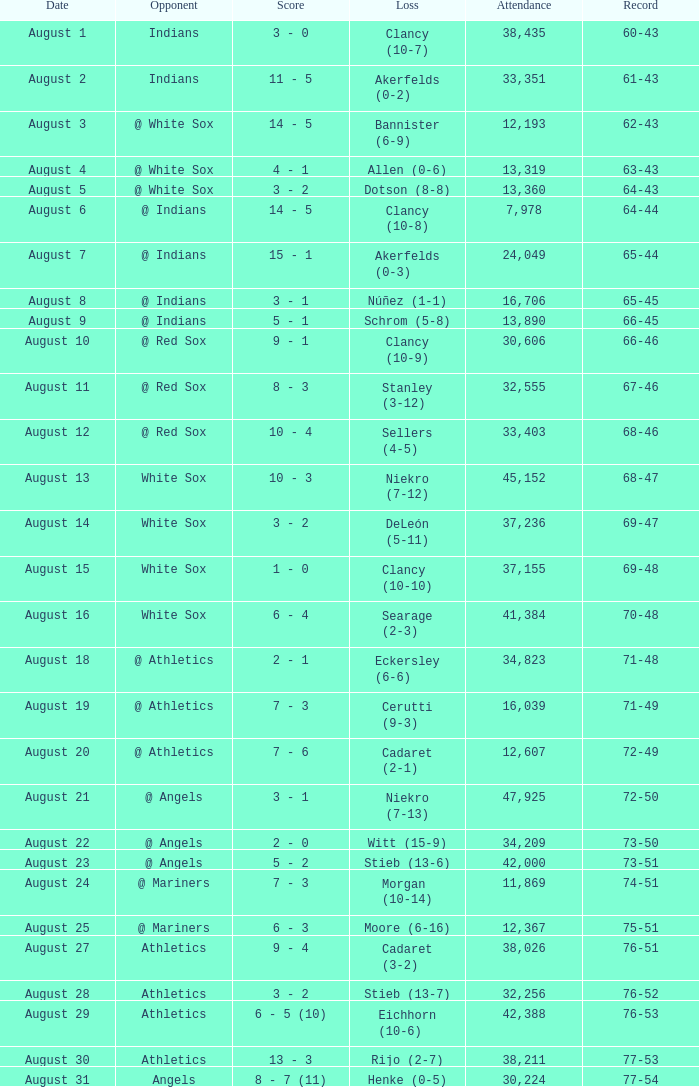What was the attendance when the record was 77-54? 30224.0. 